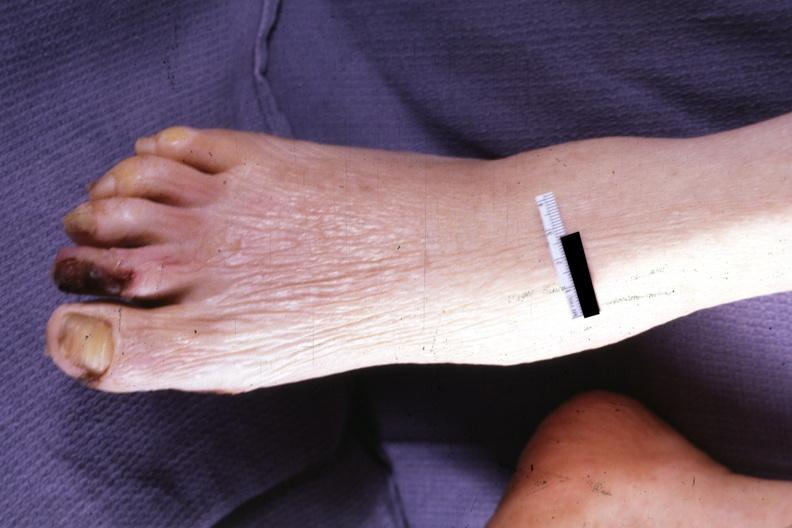what is present?
Answer the question using a single word or phrase. Gangrene 